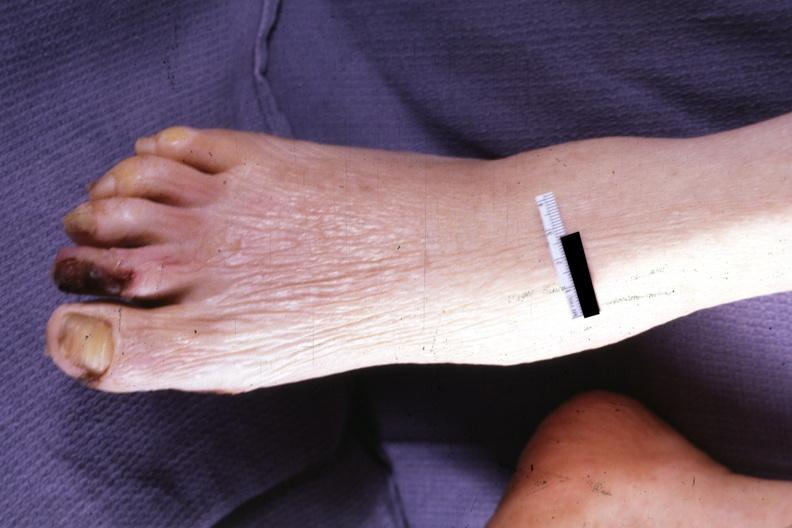what is present?
Answer the question using a single word or phrase. Gangrene 